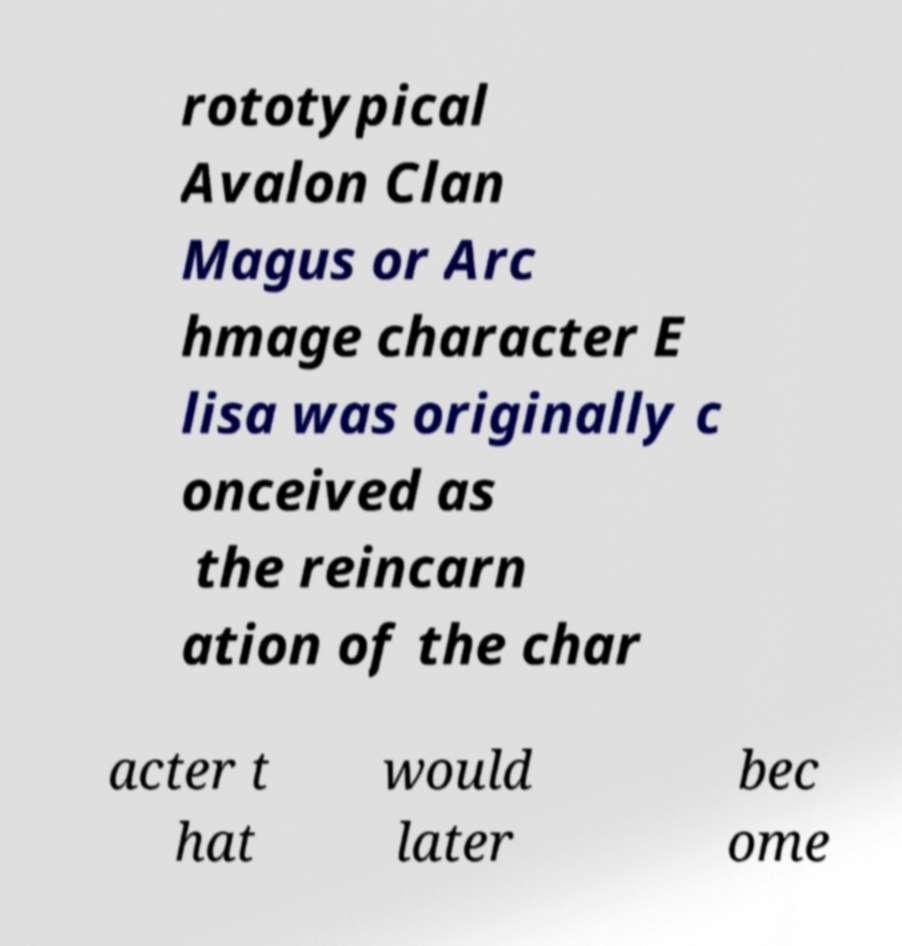Could you extract and type out the text from this image? rototypical Avalon Clan Magus or Arc hmage character E lisa was originally c onceived as the reincarn ation of the char acter t hat would later bec ome 